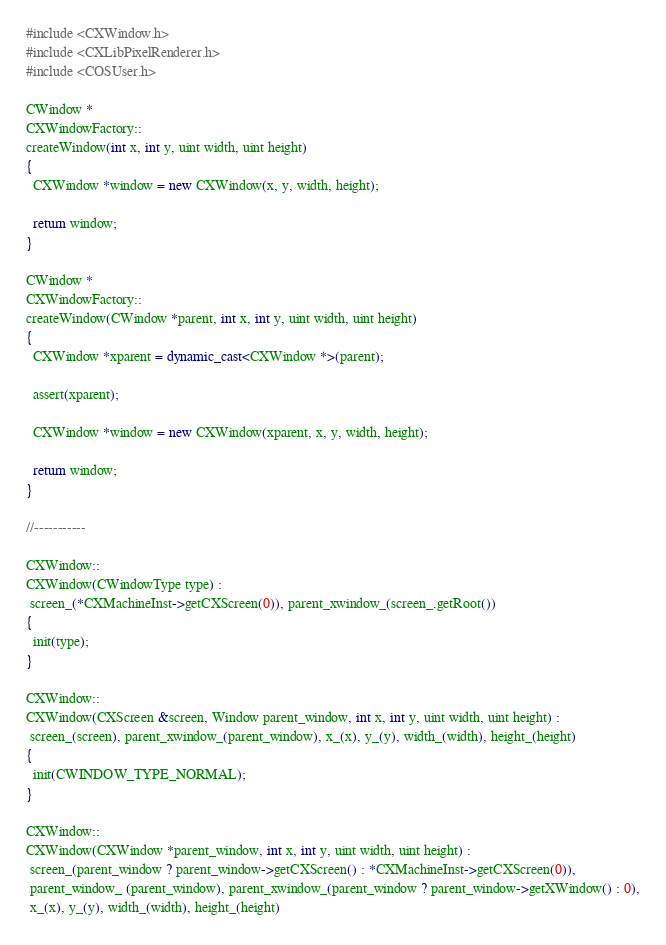Convert code to text. <code><loc_0><loc_0><loc_500><loc_500><_C++_>#include <CXWindow.h>
#include <CXLibPixelRenderer.h>
#include <COSUser.h>

CWindow *
CXWindowFactory::
createWindow(int x, int y, uint width, uint height)
{
  CXWindow *window = new CXWindow(x, y, width, height);

  return window;
}

CWindow *
CXWindowFactory::
createWindow(CWindow *parent, int x, int y, uint width, uint height)
{
  CXWindow *xparent = dynamic_cast<CXWindow *>(parent);

  assert(xparent);

  CXWindow *window = new CXWindow(xparent, x, y, width, height);

  return window;
}

//-----------

CXWindow::
CXWindow(CWindowType type) :
 screen_(*CXMachineInst->getCXScreen(0)), parent_xwindow_(screen_.getRoot())
{
  init(type);
}

CXWindow::
CXWindow(CXScreen &screen, Window parent_window, int x, int y, uint width, uint height) :
 screen_(screen), parent_xwindow_(parent_window), x_(x), y_(y), width_(width), height_(height)
{
  init(CWINDOW_TYPE_NORMAL);
}

CXWindow::
CXWindow(CXWindow *parent_window, int x, int y, uint width, uint height) :
 screen_(parent_window ? parent_window->getCXScreen() : *CXMachineInst->getCXScreen(0)),
 parent_window_ (parent_window), parent_xwindow_(parent_window ? parent_window->getXWindow() : 0),
 x_(x), y_(y), width_(width), height_(height)</code> 